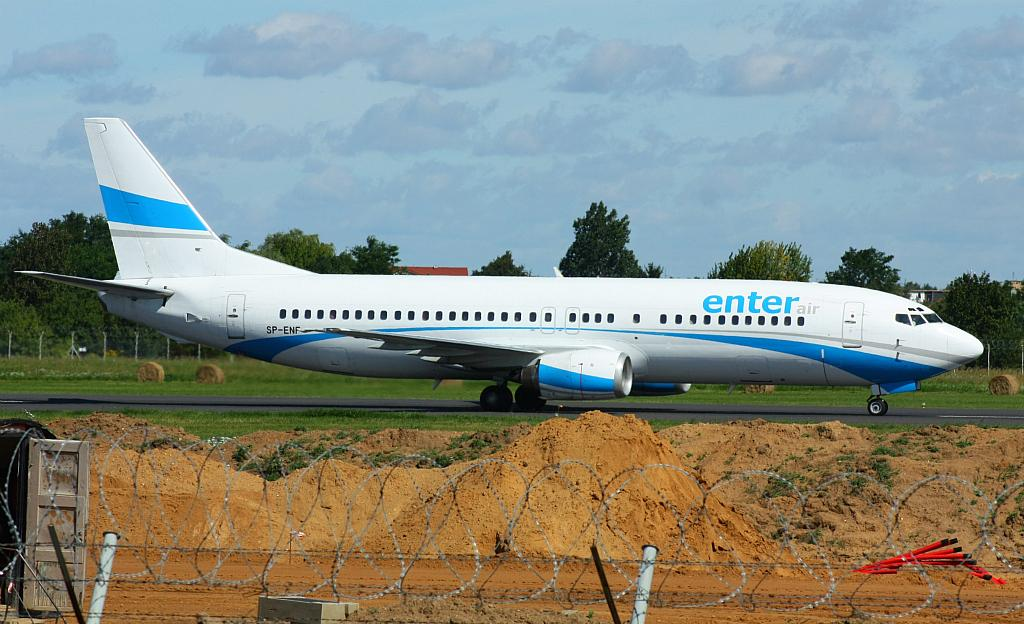<image>
Describe the image concisely. the enter plane is sitting on the runway, under a blue sky 